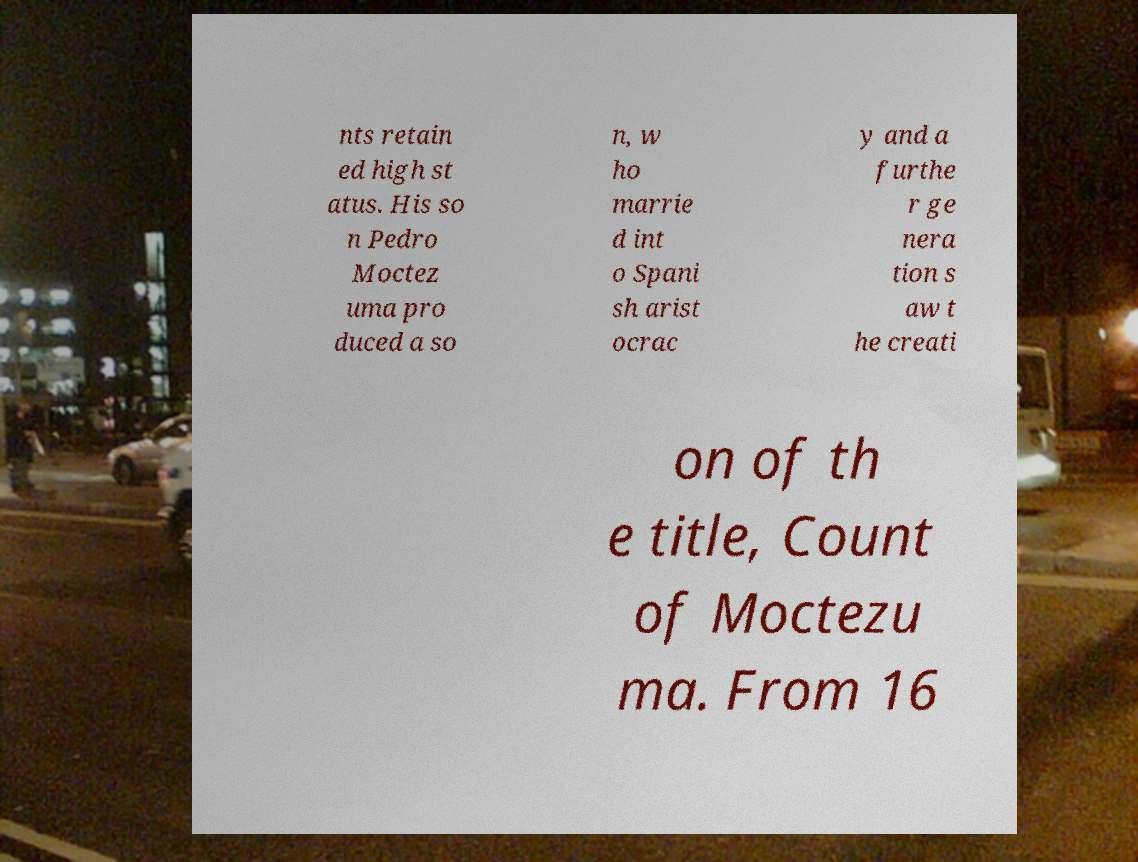For documentation purposes, I need the text within this image transcribed. Could you provide that? nts retain ed high st atus. His so n Pedro Moctez uma pro duced a so n, w ho marrie d int o Spani sh arist ocrac y and a furthe r ge nera tion s aw t he creati on of th e title, Count of Moctezu ma. From 16 